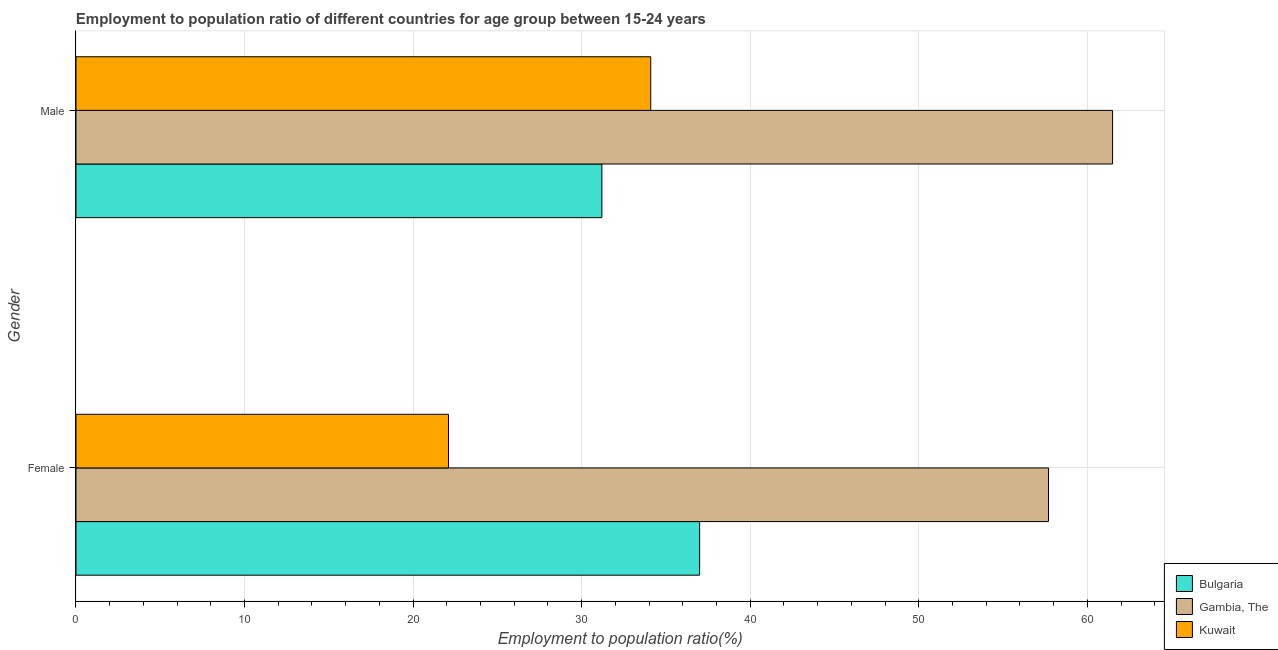How many different coloured bars are there?
Your answer should be compact. 3. Are the number of bars on each tick of the Y-axis equal?
Your answer should be compact. Yes. How many bars are there on the 1st tick from the top?
Your response must be concise. 3. How many bars are there on the 1st tick from the bottom?
Make the answer very short. 3. What is the label of the 1st group of bars from the top?
Your response must be concise. Male. What is the employment to population ratio(female) in Gambia, The?
Your response must be concise. 57.7. Across all countries, what is the maximum employment to population ratio(female)?
Ensure brevity in your answer.  57.7. Across all countries, what is the minimum employment to population ratio(male)?
Provide a short and direct response. 31.2. In which country was the employment to population ratio(male) maximum?
Make the answer very short. Gambia, The. In which country was the employment to population ratio(female) minimum?
Your response must be concise. Kuwait. What is the total employment to population ratio(male) in the graph?
Ensure brevity in your answer.  126.8. What is the difference between the employment to population ratio(male) in Bulgaria and that in Gambia, The?
Ensure brevity in your answer.  -30.3. What is the difference between the employment to population ratio(male) in Kuwait and the employment to population ratio(female) in Bulgaria?
Make the answer very short. -2.9. What is the average employment to population ratio(male) per country?
Your answer should be compact. 42.27. What is the difference between the employment to population ratio(female) and employment to population ratio(male) in Kuwait?
Provide a succinct answer. -12. In how many countries, is the employment to population ratio(female) greater than 46 %?
Keep it short and to the point. 1. What is the ratio of the employment to population ratio(male) in Kuwait to that in Bulgaria?
Offer a terse response. 1.09. Is the employment to population ratio(female) in Gambia, The less than that in Kuwait?
Offer a terse response. No. In how many countries, is the employment to population ratio(female) greater than the average employment to population ratio(female) taken over all countries?
Your response must be concise. 1. What does the 2nd bar from the top in Male represents?
Provide a succinct answer. Gambia, The. What does the 3rd bar from the bottom in Female represents?
Your answer should be compact. Kuwait. What is the difference between two consecutive major ticks on the X-axis?
Provide a succinct answer. 10. Are the values on the major ticks of X-axis written in scientific E-notation?
Your response must be concise. No. Does the graph contain grids?
Ensure brevity in your answer.  Yes. What is the title of the graph?
Provide a succinct answer. Employment to population ratio of different countries for age group between 15-24 years. Does "Central African Republic" appear as one of the legend labels in the graph?
Offer a very short reply. No. What is the Employment to population ratio(%) in Gambia, The in Female?
Ensure brevity in your answer.  57.7. What is the Employment to population ratio(%) in Kuwait in Female?
Your answer should be very brief. 22.1. What is the Employment to population ratio(%) of Bulgaria in Male?
Give a very brief answer. 31.2. What is the Employment to population ratio(%) in Gambia, The in Male?
Offer a very short reply. 61.5. What is the Employment to population ratio(%) of Kuwait in Male?
Your response must be concise. 34.1. Across all Gender, what is the maximum Employment to population ratio(%) of Bulgaria?
Your response must be concise. 37. Across all Gender, what is the maximum Employment to population ratio(%) of Gambia, The?
Ensure brevity in your answer.  61.5. Across all Gender, what is the maximum Employment to population ratio(%) in Kuwait?
Provide a short and direct response. 34.1. Across all Gender, what is the minimum Employment to population ratio(%) of Bulgaria?
Your answer should be compact. 31.2. Across all Gender, what is the minimum Employment to population ratio(%) in Gambia, The?
Make the answer very short. 57.7. Across all Gender, what is the minimum Employment to population ratio(%) of Kuwait?
Ensure brevity in your answer.  22.1. What is the total Employment to population ratio(%) in Bulgaria in the graph?
Ensure brevity in your answer.  68.2. What is the total Employment to population ratio(%) in Gambia, The in the graph?
Provide a succinct answer. 119.2. What is the total Employment to population ratio(%) of Kuwait in the graph?
Provide a succinct answer. 56.2. What is the difference between the Employment to population ratio(%) in Gambia, The in Female and that in Male?
Your answer should be very brief. -3.8. What is the difference between the Employment to population ratio(%) in Bulgaria in Female and the Employment to population ratio(%) in Gambia, The in Male?
Provide a short and direct response. -24.5. What is the difference between the Employment to population ratio(%) in Bulgaria in Female and the Employment to population ratio(%) in Kuwait in Male?
Give a very brief answer. 2.9. What is the difference between the Employment to population ratio(%) in Gambia, The in Female and the Employment to population ratio(%) in Kuwait in Male?
Give a very brief answer. 23.6. What is the average Employment to population ratio(%) in Bulgaria per Gender?
Offer a very short reply. 34.1. What is the average Employment to population ratio(%) in Gambia, The per Gender?
Your response must be concise. 59.6. What is the average Employment to population ratio(%) of Kuwait per Gender?
Give a very brief answer. 28.1. What is the difference between the Employment to population ratio(%) of Bulgaria and Employment to population ratio(%) of Gambia, The in Female?
Your answer should be compact. -20.7. What is the difference between the Employment to population ratio(%) of Gambia, The and Employment to population ratio(%) of Kuwait in Female?
Your response must be concise. 35.6. What is the difference between the Employment to population ratio(%) in Bulgaria and Employment to population ratio(%) in Gambia, The in Male?
Your answer should be compact. -30.3. What is the difference between the Employment to population ratio(%) of Gambia, The and Employment to population ratio(%) of Kuwait in Male?
Provide a succinct answer. 27.4. What is the ratio of the Employment to population ratio(%) of Bulgaria in Female to that in Male?
Your answer should be compact. 1.19. What is the ratio of the Employment to population ratio(%) of Gambia, The in Female to that in Male?
Provide a succinct answer. 0.94. What is the ratio of the Employment to population ratio(%) of Kuwait in Female to that in Male?
Provide a succinct answer. 0.65. What is the difference between the highest and the second highest Employment to population ratio(%) of Bulgaria?
Make the answer very short. 5.8. What is the difference between the highest and the second highest Employment to population ratio(%) of Gambia, The?
Offer a terse response. 3.8. What is the difference between the highest and the second highest Employment to population ratio(%) of Kuwait?
Provide a succinct answer. 12. What is the difference between the highest and the lowest Employment to population ratio(%) of Gambia, The?
Provide a short and direct response. 3.8. 